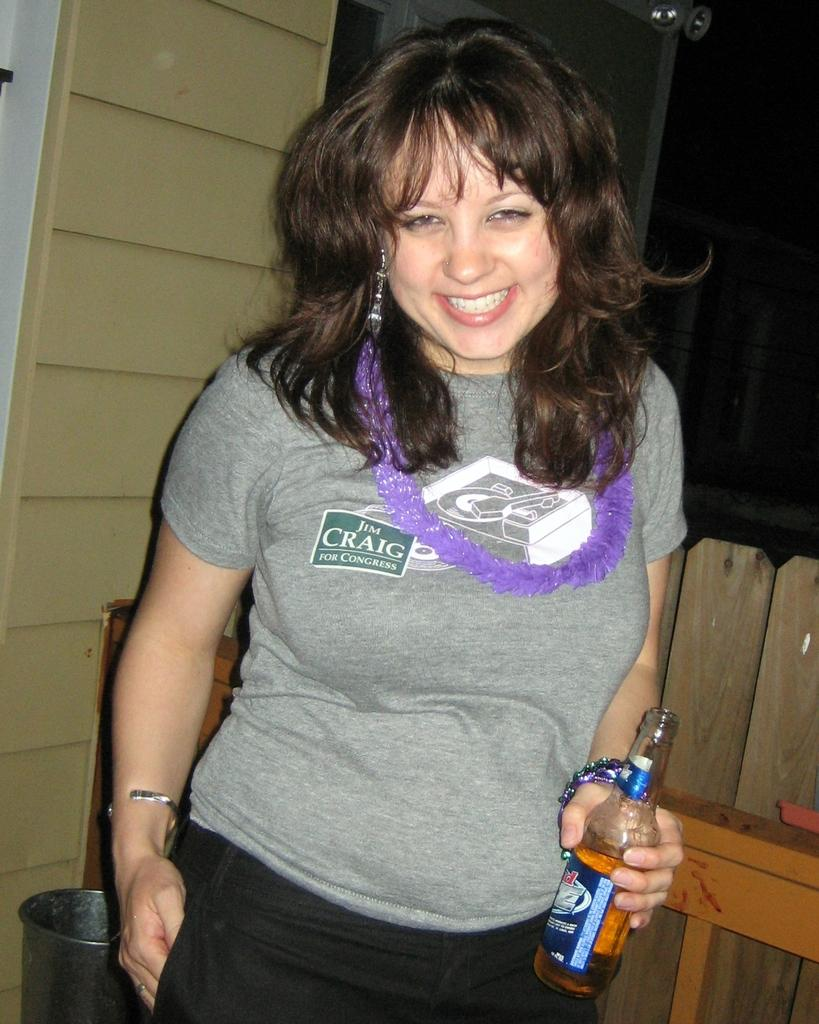Who is the main subject in the image? There is a woman in the image. What is the woman doing in the image? The woman is posing for a camera. What object is the woman holding in her hand? The woman is holding a wine bottle in her hand. How does the woman react to the earthquake in the image? There is no earthquake present in the image, so the woman's reaction cannot be determined. 